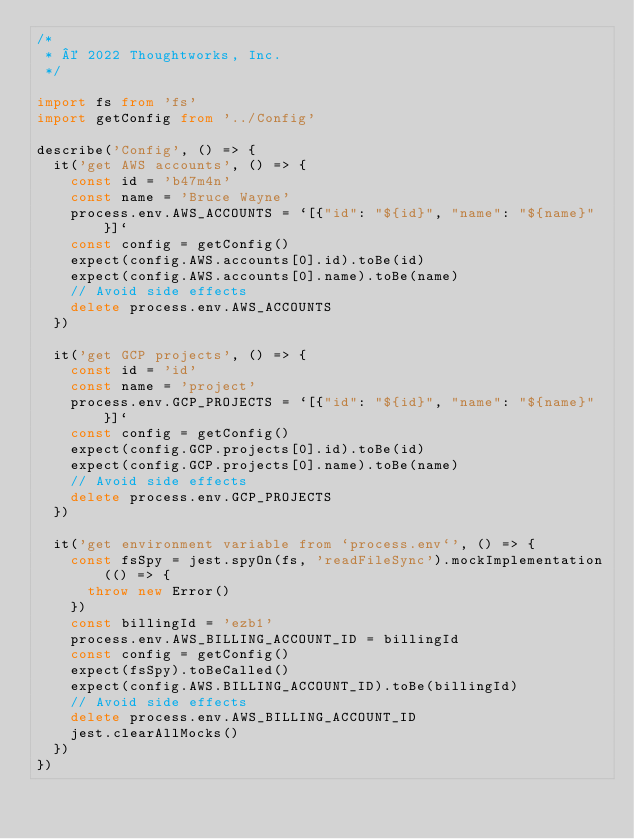Convert code to text. <code><loc_0><loc_0><loc_500><loc_500><_TypeScript_>/*
 * © 2022 Thoughtworks, Inc.
 */

import fs from 'fs'
import getConfig from '../Config'

describe('Config', () => {
  it('get AWS accounts', () => {
    const id = 'b47m4n'
    const name = 'Bruce Wayne'
    process.env.AWS_ACCOUNTS = `[{"id": "${id}", "name": "${name}"}]`
    const config = getConfig()
    expect(config.AWS.accounts[0].id).toBe(id)
    expect(config.AWS.accounts[0].name).toBe(name)
    // Avoid side effects
    delete process.env.AWS_ACCOUNTS
  })

  it('get GCP projects', () => {
    const id = 'id'
    const name = 'project'
    process.env.GCP_PROJECTS = `[{"id": "${id}", "name": "${name}"}]`
    const config = getConfig()
    expect(config.GCP.projects[0].id).toBe(id)
    expect(config.GCP.projects[0].name).toBe(name)
    // Avoid side effects
    delete process.env.GCP_PROJECTS
  })

  it('get environment variable from `process.env`', () => {
    const fsSpy = jest.spyOn(fs, 'readFileSync').mockImplementation(() => {
      throw new Error()
    })
    const billingId = 'ezb1'
    process.env.AWS_BILLING_ACCOUNT_ID = billingId
    const config = getConfig()
    expect(fsSpy).toBeCalled()
    expect(config.AWS.BILLING_ACCOUNT_ID).toBe(billingId)
    // Avoid side effects
    delete process.env.AWS_BILLING_ACCOUNT_ID
    jest.clearAllMocks()
  })
})
</code> 